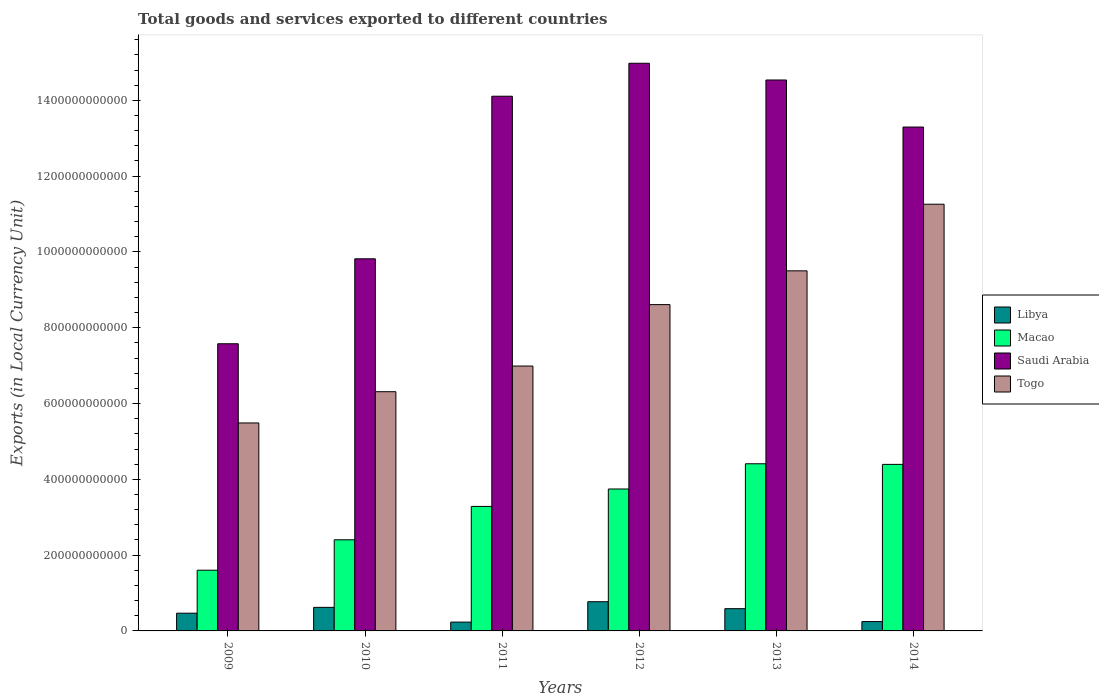How many different coloured bars are there?
Offer a very short reply. 4. How many groups of bars are there?
Offer a very short reply. 6. Are the number of bars on each tick of the X-axis equal?
Offer a very short reply. Yes. How many bars are there on the 5th tick from the left?
Keep it short and to the point. 4. How many bars are there on the 2nd tick from the right?
Your answer should be compact. 4. What is the label of the 2nd group of bars from the left?
Provide a short and direct response. 2010. In how many cases, is the number of bars for a given year not equal to the number of legend labels?
Provide a succinct answer. 0. What is the Amount of goods and services exports in Libya in 2011?
Your answer should be very brief. 2.33e+1. Across all years, what is the maximum Amount of goods and services exports in Togo?
Provide a short and direct response. 1.13e+12. Across all years, what is the minimum Amount of goods and services exports in Saudi Arabia?
Your answer should be compact. 7.58e+11. In which year was the Amount of goods and services exports in Macao maximum?
Ensure brevity in your answer.  2013. In which year was the Amount of goods and services exports in Libya minimum?
Make the answer very short. 2011. What is the total Amount of goods and services exports in Togo in the graph?
Offer a terse response. 4.82e+12. What is the difference between the Amount of goods and services exports in Macao in 2012 and that in 2013?
Offer a very short reply. -6.66e+1. What is the difference between the Amount of goods and services exports in Libya in 2010 and the Amount of goods and services exports in Macao in 2014?
Your answer should be compact. -3.77e+11. What is the average Amount of goods and services exports in Macao per year?
Give a very brief answer. 3.31e+11. In the year 2011, what is the difference between the Amount of goods and services exports in Saudi Arabia and Amount of goods and services exports in Macao?
Your response must be concise. 1.08e+12. What is the ratio of the Amount of goods and services exports in Libya in 2011 to that in 2012?
Provide a short and direct response. 0.3. Is the difference between the Amount of goods and services exports in Saudi Arabia in 2010 and 2012 greater than the difference between the Amount of goods and services exports in Macao in 2010 and 2012?
Your response must be concise. No. What is the difference between the highest and the second highest Amount of goods and services exports in Libya?
Give a very brief answer. 1.49e+1. What is the difference between the highest and the lowest Amount of goods and services exports in Libya?
Make the answer very short. 5.38e+1. Is it the case that in every year, the sum of the Amount of goods and services exports in Libya and Amount of goods and services exports in Togo is greater than the sum of Amount of goods and services exports in Macao and Amount of goods and services exports in Saudi Arabia?
Offer a very short reply. No. What does the 2nd bar from the left in 2012 represents?
Keep it short and to the point. Macao. What does the 2nd bar from the right in 2012 represents?
Provide a short and direct response. Saudi Arabia. Is it the case that in every year, the sum of the Amount of goods and services exports in Libya and Amount of goods and services exports in Togo is greater than the Amount of goods and services exports in Macao?
Give a very brief answer. Yes. How many bars are there?
Provide a succinct answer. 24. How many years are there in the graph?
Provide a short and direct response. 6. What is the difference between two consecutive major ticks on the Y-axis?
Offer a very short reply. 2.00e+11. Are the values on the major ticks of Y-axis written in scientific E-notation?
Keep it short and to the point. No. Does the graph contain any zero values?
Your answer should be very brief. No. Does the graph contain grids?
Offer a terse response. No. Where does the legend appear in the graph?
Offer a terse response. Center right. How many legend labels are there?
Keep it short and to the point. 4. What is the title of the graph?
Ensure brevity in your answer.  Total goods and services exported to different countries. What is the label or title of the X-axis?
Give a very brief answer. Years. What is the label or title of the Y-axis?
Ensure brevity in your answer.  Exports (in Local Currency Unit). What is the Exports (in Local Currency Unit) in Libya in 2009?
Provide a succinct answer. 4.68e+1. What is the Exports (in Local Currency Unit) of Macao in 2009?
Make the answer very short. 1.60e+11. What is the Exports (in Local Currency Unit) in Saudi Arabia in 2009?
Your response must be concise. 7.58e+11. What is the Exports (in Local Currency Unit) in Togo in 2009?
Offer a very short reply. 5.49e+11. What is the Exports (in Local Currency Unit) in Libya in 2010?
Offer a terse response. 6.21e+1. What is the Exports (in Local Currency Unit) in Macao in 2010?
Your answer should be very brief. 2.40e+11. What is the Exports (in Local Currency Unit) in Saudi Arabia in 2010?
Make the answer very short. 9.82e+11. What is the Exports (in Local Currency Unit) of Togo in 2010?
Your response must be concise. 6.31e+11. What is the Exports (in Local Currency Unit) in Libya in 2011?
Your response must be concise. 2.33e+1. What is the Exports (in Local Currency Unit) in Macao in 2011?
Your answer should be very brief. 3.29e+11. What is the Exports (in Local Currency Unit) of Saudi Arabia in 2011?
Give a very brief answer. 1.41e+12. What is the Exports (in Local Currency Unit) in Togo in 2011?
Your answer should be very brief. 6.99e+11. What is the Exports (in Local Currency Unit) of Libya in 2012?
Your answer should be very brief. 7.71e+1. What is the Exports (in Local Currency Unit) of Macao in 2012?
Keep it short and to the point. 3.74e+11. What is the Exports (in Local Currency Unit) of Saudi Arabia in 2012?
Offer a very short reply. 1.50e+12. What is the Exports (in Local Currency Unit) in Togo in 2012?
Give a very brief answer. 8.61e+11. What is the Exports (in Local Currency Unit) in Libya in 2013?
Offer a very short reply. 5.87e+1. What is the Exports (in Local Currency Unit) of Macao in 2013?
Give a very brief answer. 4.41e+11. What is the Exports (in Local Currency Unit) of Saudi Arabia in 2013?
Provide a short and direct response. 1.45e+12. What is the Exports (in Local Currency Unit) of Togo in 2013?
Your response must be concise. 9.50e+11. What is the Exports (in Local Currency Unit) of Libya in 2014?
Provide a succinct answer. 2.46e+1. What is the Exports (in Local Currency Unit) of Macao in 2014?
Keep it short and to the point. 4.39e+11. What is the Exports (in Local Currency Unit) in Saudi Arabia in 2014?
Provide a short and direct response. 1.33e+12. What is the Exports (in Local Currency Unit) in Togo in 2014?
Offer a very short reply. 1.13e+12. Across all years, what is the maximum Exports (in Local Currency Unit) of Libya?
Provide a short and direct response. 7.71e+1. Across all years, what is the maximum Exports (in Local Currency Unit) of Macao?
Keep it short and to the point. 4.41e+11. Across all years, what is the maximum Exports (in Local Currency Unit) in Saudi Arabia?
Make the answer very short. 1.50e+12. Across all years, what is the maximum Exports (in Local Currency Unit) of Togo?
Your answer should be very brief. 1.13e+12. Across all years, what is the minimum Exports (in Local Currency Unit) in Libya?
Your response must be concise. 2.33e+1. Across all years, what is the minimum Exports (in Local Currency Unit) of Macao?
Offer a very short reply. 1.60e+11. Across all years, what is the minimum Exports (in Local Currency Unit) in Saudi Arabia?
Your response must be concise. 7.58e+11. Across all years, what is the minimum Exports (in Local Currency Unit) of Togo?
Provide a succinct answer. 5.49e+11. What is the total Exports (in Local Currency Unit) in Libya in the graph?
Make the answer very short. 2.93e+11. What is the total Exports (in Local Currency Unit) in Macao in the graph?
Your answer should be very brief. 1.98e+12. What is the total Exports (in Local Currency Unit) of Saudi Arabia in the graph?
Give a very brief answer. 7.43e+12. What is the total Exports (in Local Currency Unit) of Togo in the graph?
Your answer should be compact. 4.82e+12. What is the difference between the Exports (in Local Currency Unit) of Libya in 2009 and that in 2010?
Give a very brief answer. -1.53e+1. What is the difference between the Exports (in Local Currency Unit) in Macao in 2009 and that in 2010?
Your response must be concise. -8.02e+1. What is the difference between the Exports (in Local Currency Unit) of Saudi Arabia in 2009 and that in 2010?
Your answer should be compact. -2.24e+11. What is the difference between the Exports (in Local Currency Unit) of Togo in 2009 and that in 2010?
Your response must be concise. -8.24e+1. What is the difference between the Exports (in Local Currency Unit) in Libya in 2009 and that in 2011?
Offer a terse response. 2.35e+1. What is the difference between the Exports (in Local Currency Unit) of Macao in 2009 and that in 2011?
Offer a terse response. -1.68e+11. What is the difference between the Exports (in Local Currency Unit) in Saudi Arabia in 2009 and that in 2011?
Provide a short and direct response. -6.53e+11. What is the difference between the Exports (in Local Currency Unit) in Togo in 2009 and that in 2011?
Give a very brief answer. -1.50e+11. What is the difference between the Exports (in Local Currency Unit) of Libya in 2009 and that in 2012?
Your response must be concise. -3.03e+1. What is the difference between the Exports (in Local Currency Unit) of Macao in 2009 and that in 2012?
Make the answer very short. -2.14e+11. What is the difference between the Exports (in Local Currency Unit) in Saudi Arabia in 2009 and that in 2012?
Your answer should be very brief. -7.40e+11. What is the difference between the Exports (in Local Currency Unit) in Togo in 2009 and that in 2012?
Offer a terse response. -3.12e+11. What is the difference between the Exports (in Local Currency Unit) of Libya in 2009 and that in 2013?
Provide a succinct answer. -1.19e+1. What is the difference between the Exports (in Local Currency Unit) in Macao in 2009 and that in 2013?
Offer a terse response. -2.81e+11. What is the difference between the Exports (in Local Currency Unit) in Saudi Arabia in 2009 and that in 2013?
Make the answer very short. -6.96e+11. What is the difference between the Exports (in Local Currency Unit) of Togo in 2009 and that in 2013?
Make the answer very short. -4.01e+11. What is the difference between the Exports (in Local Currency Unit) of Libya in 2009 and that in 2014?
Provide a succinct answer. 2.22e+1. What is the difference between the Exports (in Local Currency Unit) in Macao in 2009 and that in 2014?
Provide a succinct answer. -2.79e+11. What is the difference between the Exports (in Local Currency Unit) in Saudi Arabia in 2009 and that in 2014?
Ensure brevity in your answer.  -5.72e+11. What is the difference between the Exports (in Local Currency Unit) in Togo in 2009 and that in 2014?
Provide a succinct answer. -5.77e+11. What is the difference between the Exports (in Local Currency Unit) in Libya in 2010 and that in 2011?
Make the answer very short. 3.89e+1. What is the difference between the Exports (in Local Currency Unit) of Macao in 2010 and that in 2011?
Provide a succinct answer. -8.81e+1. What is the difference between the Exports (in Local Currency Unit) in Saudi Arabia in 2010 and that in 2011?
Your answer should be very brief. -4.29e+11. What is the difference between the Exports (in Local Currency Unit) of Togo in 2010 and that in 2011?
Offer a very short reply. -6.77e+1. What is the difference between the Exports (in Local Currency Unit) of Libya in 2010 and that in 2012?
Give a very brief answer. -1.49e+1. What is the difference between the Exports (in Local Currency Unit) of Macao in 2010 and that in 2012?
Keep it short and to the point. -1.34e+11. What is the difference between the Exports (in Local Currency Unit) in Saudi Arabia in 2010 and that in 2012?
Give a very brief answer. -5.16e+11. What is the difference between the Exports (in Local Currency Unit) in Togo in 2010 and that in 2012?
Give a very brief answer. -2.30e+11. What is the difference between the Exports (in Local Currency Unit) of Libya in 2010 and that in 2013?
Offer a terse response. 3.47e+09. What is the difference between the Exports (in Local Currency Unit) in Macao in 2010 and that in 2013?
Your response must be concise. -2.01e+11. What is the difference between the Exports (in Local Currency Unit) of Saudi Arabia in 2010 and that in 2013?
Your answer should be very brief. -4.72e+11. What is the difference between the Exports (in Local Currency Unit) in Togo in 2010 and that in 2013?
Provide a succinct answer. -3.19e+11. What is the difference between the Exports (in Local Currency Unit) in Libya in 2010 and that in 2014?
Your response must be concise. 3.75e+1. What is the difference between the Exports (in Local Currency Unit) in Macao in 2010 and that in 2014?
Give a very brief answer. -1.99e+11. What is the difference between the Exports (in Local Currency Unit) in Saudi Arabia in 2010 and that in 2014?
Offer a very short reply. -3.48e+11. What is the difference between the Exports (in Local Currency Unit) in Togo in 2010 and that in 2014?
Provide a succinct answer. -4.95e+11. What is the difference between the Exports (in Local Currency Unit) in Libya in 2011 and that in 2012?
Offer a very short reply. -5.38e+1. What is the difference between the Exports (in Local Currency Unit) in Macao in 2011 and that in 2012?
Ensure brevity in your answer.  -4.60e+1. What is the difference between the Exports (in Local Currency Unit) of Saudi Arabia in 2011 and that in 2012?
Your answer should be very brief. -8.70e+1. What is the difference between the Exports (in Local Currency Unit) in Togo in 2011 and that in 2012?
Provide a succinct answer. -1.62e+11. What is the difference between the Exports (in Local Currency Unit) of Libya in 2011 and that in 2013?
Provide a short and direct response. -3.54e+1. What is the difference between the Exports (in Local Currency Unit) of Macao in 2011 and that in 2013?
Your response must be concise. -1.13e+11. What is the difference between the Exports (in Local Currency Unit) in Saudi Arabia in 2011 and that in 2013?
Offer a very short reply. -4.28e+1. What is the difference between the Exports (in Local Currency Unit) in Togo in 2011 and that in 2013?
Your answer should be very brief. -2.51e+11. What is the difference between the Exports (in Local Currency Unit) of Libya in 2011 and that in 2014?
Give a very brief answer. -1.32e+09. What is the difference between the Exports (in Local Currency Unit) of Macao in 2011 and that in 2014?
Your answer should be compact. -1.11e+11. What is the difference between the Exports (in Local Currency Unit) of Saudi Arabia in 2011 and that in 2014?
Provide a succinct answer. 8.13e+1. What is the difference between the Exports (in Local Currency Unit) in Togo in 2011 and that in 2014?
Keep it short and to the point. -4.27e+11. What is the difference between the Exports (in Local Currency Unit) of Libya in 2012 and that in 2013?
Provide a succinct answer. 1.84e+1. What is the difference between the Exports (in Local Currency Unit) in Macao in 2012 and that in 2013?
Offer a terse response. -6.66e+1. What is the difference between the Exports (in Local Currency Unit) in Saudi Arabia in 2012 and that in 2013?
Offer a terse response. 4.42e+1. What is the difference between the Exports (in Local Currency Unit) in Togo in 2012 and that in 2013?
Give a very brief answer. -8.91e+1. What is the difference between the Exports (in Local Currency Unit) of Libya in 2012 and that in 2014?
Offer a terse response. 5.25e+1. What is the difference between the Exports (in Local Currency Unit) in Macao in 2012 and that in 2014?
Give a very brief answer. -6.50e+1. What is the difference between the Exports (in Local Currency Unit) in Saudi Arabia in 2012 and that in 2014?
Keep it short and to the point. 1.68e+11. What is the difference between the Exports (in Local Currency Unit) in Togo in 2012 and that in 2014?
Your answer should be very brief. -2.65e+11. What is the difference between the Exports (in Local Currency Unit) in Libya in 2013 and that in 2014?
Keep it short and to the point. 3.41e+1. What is the difference between the Exports (in Local Currency Unit) of Macao in 2013 and that in 2014?
Ensure brevity in your answer.  1.61e+09. What is the difference between the Exports (in Local Currency Unit) of Saudi Arabia in 2013 and that in 2014?
Your answer should be compact. 1.24e+11. What is the difference between the Exports (in Local Currency Unit) in Togo in 2013 and that in 2014?
Your answer should be compact. -1.76e+11. What is the difference between the Exports (in Local Currency Unit) of Libya in 2009 and the Exports (in Local Currency Unit) of Macao in 2010?
Offer a terse response. -1.94e+11. What is the difference between the Exports (in Local Currency Unit) in Libya in 2009 and the Exports (in Local Currency Unit) in Saudi Arabia in 2010?
Offer a terse response. -9.35e+11. What is the difference between the Exports (in Local Currency Unit) of Libya in 2009 and the Exports (in Local Currency Unit) of Togo in 2010?
Keep it short and to the point. -5.84e+11. What is the difference between the Exports (in Local Currency Unit) in Macao in 2009 and the Exports (in Local Currency Unit) in Saudi Arabia in 2010?
Give a very brief answer. -8.22e+11. What is the difference between the Exports (in Local Currency Unit) in Macao in 2009 and the Exports (in Local Currency Unit) in Togo in 2010?
Give a very brief answer. -4.71e+11. What is the difference between the Exports (in Local Currency Unit) in Saudi Arabia in 2009 and the Exports (in Local Currency Unit) in Togo in 2010?
Offer a terse response. 1.27e+11. What is the difference between the Exports (in Local Currency Unit) in Libya in 2009 and the Exports (in Local Currency Unit) in Macao in 2011?
Offer a terse response. -2.82e+11. What is the difference between the Exports (in Local Currency Unit) of Libya in 2009 and the Exports (in Local Currency Unit) of Saudi Arabia in 2011?
Offer a very short reply. -1.36e+12. What is the difference between the Exports (in Local Currency Unit) in Libya in 2009 and the Exports (in Local Currency Unit) in Togo in 2011?
Provide a short and direct response. -6.52e+11. What is the difference between the Exports (in Local Currency Unit) of Macao in 2009 and the Exports (in Local Currency Unit) of Saudi Arabia in 2011?
Give a very brief answer. -1.25e+12. What is the difference between the Exports (in Local Currency Unit) in Macao in 2009 and the Exports (in Local Currency Unit) in Togo in 2011?
Keep it short and to the point. -5.39e+11. What is the difference between the Exports (in Local Currency Unit) in Saudi Arabia in 2009 and the Exports (in Local Currency Unit) in Togo in 2011?
Your answer should be very brief. 5.88e+1. What is the difference between the Exports (in Local Currency Unit) in Libya in 2009 and the Exports (in Local Currency Unit) in Macao in 2012?
Make the answer very short. -3.28e+11. What is the difference between the Exports (in Local Currency Unit) in Libya in 2009 and the Exports (in Local Currency Unit) in Saudi Arabia in 2012?
Give a very brief answer. -1.45e+12. What is the difference between the Exports (in Local Currency Unit) in Libya in 2009 and the Exports (in Local Currency Unit) in Togo in 2012?
Your answer should be very brief. -8.14e+11. What is the difference between the Exports (in Local Currency Unit) of Macao in 2009 and the Exports (in Local Currency Unit) of Saudi Arabia in 2012?
Your response must be concise. -1.34e+12. What is the difference between the Exports (in Local Currency Unit) of Macao in 2009 and the Exports (in Local Currency Unit) of Togo in 2012?
Provide a succinct answer. -7.01e+11. What is the difference between the Exports (in Local Currency Unit) of Saudi Arabia in 2009 and the Exports (in Local Currency Unit) of Togo in 2012?
Keep it short and to the point. -1.03e+11. What is the difference between the Exports (in Local Currency Unit) of Libya in 2009 and the Exports (in Local Currency Unit) of Macao in 2013?
Make the answer very short. -3.94e+11. What is the difference between the Exports (in Local Currency Unit) of Libya in 2009 and the Exports (in Local Currency Unit) of Saudi Arabia in 2013?
Your answer should be compact. -1.41e+12. What is the difference between the Exports (in Local Currency Unit) of Libya in 2009 and the Exports (in Local Currency Unit) of Togo in 2013?
Your response must be concise. -9.03e+11. What is the difference between the Exports (in Local Currency Unit) in Macao in 2009 and the Exports (in Local Currency Unit) in Saudi Arabia in 2013?
Provide a short and direct response. -1.29e+12. What is the difference between the Exports (in Local Currency Unit) of Macao in 2009 and the Exports (in Local Currency Unit) of Togo in 2013?
Keep it short and to the point. -7.90e+11. What is the difference between the Exports (in Local Currency Unit) in Saudi Arabia in 2009 and the Exports (in Local Currency Unit) in Togo in 2013?
Offer a terse response. -1.92e+11. What is the difference between the Exports (in Local Currency Unit) of Libya in 2009 and the Exports (in Local Currency Unit) of Macao in 2014?
Keep it short and to the point. -3.93e+11. What is the difference between the Exports (in Local Currency Unit) of Libya in 2009 and the Exports (in Local Currency Unit) of Saudi Arabia in 2014?
Your answer should be very brief. -1.28e+12. What is the difference between the Exports (in Local Currency Unit) of Libya in 2009 and the Exports (in Local Currency Unit) of Togo in 2014?
Your answer should be compact. -1.08e+12. What is the difference between the Exports (in Local Currency Unit) in Macao in 2009 and the Exports (in Local Currency Unit) in Saudi Arabia in 2014?
Your response must be concise. -1.17e+12. What is the difference between the Exports (in Local Currency Unit) in Macao in 2009 and the Exports (in Local Currency Unit) in Togo in 2014?
Ensure brevity in your answer.  -9.66e+11. What is the difference between the Exports (in Local Currency Unit) of Saudi Arabia in 2009 and the Exports (in Local Currency Unit) of Togo in 2014?
Ensure brevity in your answer.  -3.68e+11. What is the difference between the Exports (in Local Currency Unit) in Libya in 2010 and the Exports (in Local Currency Unit) in Macao in 2011?
Provide a short and direct response. -2.66e+11. What is the difference between the Exports (in Local Currency Unit) in Libya in 2010 and the Exports (in Local Currency Unit) in Saudi Arabia in 2011?
Keep it short and to the point. -1.35e+12. What is the difference between the Exports (in Local Currency Unit) of Libya in 2010 and the Exports (in Local Currency Unit) of Togo in 2011?
Offer a very short reply. -6.37e+11. What is the difference between the Exports (in Local Currency Unit) of Macao in 2010 and the Exports (in Local Currency Unit) of Saudi Arabia in 2011?
Provide a short and direct response. -1.17e+12. What is the difference between the Exports (in Local Currency Unit) of Macao in 2010 and the Exports (in Local Currency Unit) of Togo in 2011?
Provide a succinct answer. -4.58e+11. What is the difference between the Exports (in Local Currency Unit) of Saudi Arabia in 2010 and the Exports (in Local Currency Unit) of Togo in 2011?
Your response must be concise. 2.83e+11. What is the difference between the Exports (in Local Currency Unit) of Libya in 2010 and the Exports (in Local Currency Unit) of Macao in 2012?
Keep it short and to the point. -3.12e+11. What is the difference between the Exports (in Local Currency Unit) in Libya in 2010 and the Exports (in Local Currency Unit) in Saudi Arabia in 2012?
Give a very brief answer. -1.44e+12. What is the difference between the Exports (in Local Currency Unit) of Libya in 2010 and the Exports (in Local Currency Unit) of Togo in 2012?
Provide a succinct answer. -7.99e+11. What is the difference between the Exports (in Local Currency Unit) of Macao in 2010 and the Exports (in Local Currency Unit) of Saudi Arabia in 2012?
Make the answer very short. -1.26e+12. What is the difference between the Exports (in Local Currency Unit) in Macao in 2010 and the Exports (in Local Currency Unit) in Togo in 2012?
Offer a terse response. -6.21e+11. What is the difference between the Exports (in Local Currency Unit) of Saudi Arabia in 2010 and the Exports (in Local Currency Unit) of Togo in 2012?
Make the answer very short. 1.21e+11. What is the difference between the Exports (in Local Currency Unit) of Libya in 2010 and the Exports (in Local Currency Unit) of Macao in 2013?
Provide a succinct answer. -3.79e+11. What is the difference between the Exports (in Local Currency Unit) in Libya in 2010 and the Exports (in Local Currency Unit) in Saudi Arabia in 2013?
Offer a very short reply. -1.39e+12. What is the difference between the Exports (in Local Currency Unit) in Libya in 2010 and the Exports (in Local Currency Unit) in Togo in 2013?
Your answer should be compact. -8.88e+11. What is the difference between the Exports (in Local Currency Unit) in Macao in 2010 and the Exports (in Local Currency Unit) in Saudi Arabia in 2013?
Provide a succinct answer. -1.21e+12. What is the difference between the Exports (in Local Currency Unit) in Macao in 2010 and the Exports (in Local Currency Unit) in Togo in 2013?
Offer a very short reply. -7.10e+11. What is the difference between the Exports (in Local Currency Unit) in Saudi Arabia in 2010 and the Exports (in Local Currency Unit) in Togo in 2013?
Give a very brief answer. 3.18e+1. What is the difference between the Exports (in Local Currency Unit) in Libya in 2010 and the Exports (in Local Currency Unit) in Macao in 2014?
Your answer should be compact. -3.77e+11. What is the difference between the Exports (in Local Currency Unit) of Libya in 2010 and the Exports (in Local Currency Unit) of Saudi Arabia in 2014?
Your response must be concise. -1.27e+12. What is the difference between the Exports (in Local Currency Unit) in Libya in 2010 and the Exports (in Local Currency Unit) in Togo in 2014?
Your answer should be compact. -1.06e+12. What is the difference between the Exports (in Local Currency Unit) in Macao in 2010 and the Exports (in Local Currency Unit) in Saudi Arabia in 2014?
Offer a very short reply. -1.09e+12. What is the difference between the Exports (in Local Currency Unit) of Macao in 2010 and the Exports (in Local Currency Unit) of Togo in 2014?
Your answer should be compact. -8.85e+11. What is the difference between the Exports (in Local Currency Unit) of Saudi Arabia in 2010 and the Exports (in Local Currency Unit) of Togo in 2014?
Your answer should be very brief. -1.44e+11. What is the difference between the Exports (in Local Currency Unit) of Libya in 2011 and the Exports (in Local Currency Unit) of Macao in 2012?
Your answer should be very brief. -3.51e+11. What is the difference between the Exports (in Local Currency Unit) in Libya in 2011 and the Exports (in Local Currency Unit) in Saudi Arabia in 2012?
Provide a short and direct response. -1.47e+12. What is the difference between the Exports (in Local Currency Unit) in Libya in 2011 and the Exports (in Local Currency Unit) in Togo in 2012?
Your response must be concise. -8.38e+11. What is the difference between the Exports (in Local Currency Unit) of Macao in 2011 and the Exports (in Local Currency Unit) of Saudi Arabia in 2012?
Ensure brevity in your answer.  -1.17e+12. What is the difference between the Exports (in Local Currency Unit) in Macao in 2011 and the Exports (in Local Currency Unit) in Togo in 2012?
Give a very brief answer. -5.32e+11. What is the difference between the Exports (in Local Currency Unit) in Saudi Arabia in 2011 and the Exports (in Local Currency Unit) in Togo in 2012?
Ensure brevity in your answer.  5.50e+11. What is the difference between the Exports (in Local Currency Unit) of Libya in 2011 and the Exports (in Local Currency Unit) of Macao in 2013?
Make the answer very short. -4.18e+11. What is the difference between the Exports (in Local Currency Unit) of Libya in 2011 and the Exports (in Local Currency Unit) of Saudi Arabia in 2013?
Provide a short and direct response. -1.43e+12. What is the difference between the Exports (in Local Currency Unit) in Libya in 2011 and the Exports (in Local Currency Unit) in Togo in 2013?
Your response must be concise. -9.27e+11. What is the difference between the Exports (in Local Currency Unit) in Macao in 2011 and the Exports (in Local Currency Unit) in Saudi Arabia in 2013?
Offer a terse response. -1.13e+12. What is the difference between the Exports (in Local Currency Unit) of Macao in 2011 and the Exports (in Local Currency Unit) of Togo in 2013?
Your answer should be compact. -6.22e+11. What is the difference between the Exports (in Local Currency Unit) of Saudi Arabia in 2011 and the Exports (in Local Currency Unit) of Togo in 2013?
Ensure brevity in your answer.  4.61e+11. What is the difference between the Exports (in Local Currency Unit) of Libya in 2011 and the Exports (in Local Currency Unit) of Macao in 2014?
Offer a very short reply. -4.16e+11. What is the difference between the Exports (in Local Currency Unit) of Libya in 2011 and the Exports (in Local Currency Unit) of Saudi Arabia in 2014?
Offer a very short reply. -1.31e+12. What is the difference between the Exports (in Local Currency Unit) of Libya in 2011 and the Exports (in Local Currency Unit) of Togo in 2014?
Keep it short and to the point. -1.10e+12. What is the difference between the Exports (in Local Currency Unit) of Macao in 2011 and the Exports (in Local Currency Unit) of Saudi Arabia in 2014?
Make the answer very short. -1.00e+12. What is the difference between the Exports (in Local Currency Unit) of Macao in 2011 and the Exports (in Local Currency Unit) of Togo in 2014?
Offer a terse response. -7.97e+11. What is the difference between the Exports (in Local Currency Unit) in Saudi Arabia in 2011 and the Exports (in Local Currency Unit) in Togo in 2014?
Your answer should be compact. 2.85e+11. What is the difference between the Exports (in Local Currency Unit) in Libya in 2012 and the Exports (in Local Currency Unit) in Macao in 2013?
Give a very brief answer. -3.64e+11. What is the difference between the Exports (in Local Currency Unit) in Libya in 2012 and the Exports (in Local Currency Unit) in Saudi Arabia in 2013?
Provide a succinct answer. -1.38e+12. What is the difference between the Exports (in Local Currency Unit) in Libya in 2012 and the Exports (in Local Currency Unit) in Togo in 2013?
Your answer should be compact. -8.73e+11. What is the difference between the Exports (in Local Currency Unit) of Macao in 2012 and the Exports (in Local Currency Unit) of Saudi Arabia in 2013?
Your answer should be compact. -1.08e+12. What is the difference between the Exports (in Local Currency Unit) of Macao in 2012 and the Exports (in Local Currency Unit) of Togo in 2013?
Your answer should be compact. -5.76e+11. What is the difference between the Exports (in Local Currency Unit) of Saudi Arabia in 2012 and the Exports (in Local Currency Unit) of Togo in 2013?
Offer a very short reply. 5.48e+11. What is the difference between the Exports (in Local Currency Unit) of Libya in 2012 and the Exports (in Local Currency Unit) of Macao in 2014?
Provide a succinct answer. -3.62e+11. What is the difference between the Exports (in Local Currency Unit) of Libya in 2012 and the Exports (in Local Currency Unit) of Saudi Arabia in 2014?
Give a very brief answer. -1.25e+12. What is the difference between the Exports (in Local Currency Unit) of Libya in 2012 and the Exports (in Local Currency Unit) of Togo in 2014?
Your answer should be very brief. -1.05e+12. What is the difference between the Exports (in Local Currency Unit) in Macao in 2012 and the Exports (in Local Currency Unit) in Saudi Arabia in 2014?
Offer a very short reply. -9.55e+11. What is the difference between the Exports (in Local Currency Unit) of Macao in 2012 and the Exports (in Local Currency Unit) of Togo in 2014?
Keep it short and to the point. -7.51e+11. What is the difference between the Exports (in Local Currency Unit) of Saudi Arabia in 2012 and the Exports (in Local Currency Unit) of Togo in 2014?
Make the answer very short. 3.72e+11. What is the difference between the Exports (in Local Currency Unit) of Libya in 2013 and the Exports (in Local Currency Unit) of Macao in 2014?
Offer a very short reply. -3.81e+11. What is the difference between the Exports (in Local Currency Unit) in Libya in 2013 and the Exports (in Local Currency Unit) in Saudi Arabia in 2014?
Your response must be concise. -1.27e+12. What is the difference between the Exports (in Local Currency Unit) of Libya in 2013 and the Exports (in Local Currency Unit) of Togo in 2014?
Offer a terse response. -1.07e+12. What is the difference between the Exports (in Local Currency Unit) of Macao in 2013 and the Exports (in Local Currency Unit) of Saudi Arabia in 2014?
Your response must be concise. -8.88e+11. What is the difference between the Exports (in Local Currency Unit) in Macao in 2013 and the Exports (in Local Currency Unit) in Togo in 2014?
Keep it short and to the point. -6.85e+11. What is the difference between the Exports (in Local Currency Unit) in Saudi Arabia in 2013 and the Exports (in Local Currency Unit) in Togo in 2014?
Provide a short and direct response. 3.28e+11. What is the average Exports (in Local Currency Unit) in Libya per year?
Offer a terse response. 4.88e+1. What is the average Exports (in Local Currency Unit) of Macao per year?
Provide a succinct answer. 3.31e+11. What is the average Exports (in Local Currency Unit) of Saudi Arabia per year?
Ensure brevity in your answer.  1.24e+12. What is the average Exports (in Local Currency Unit) of Togo per year?
Keep it short and to the point. 8.03e+11. In the year 2009, what is the difference between the Exports (in Local Currency Unit) in Libya and Exports (in Local Currency Unit) in Macao?
Your answer should be compact. -1.13e+11. In the year 2009, what is the difference between the Exports (in Local Currency Unit) in Libya and Exports (in Local Currency Unit) in Saudi Arabia?
Give a very brief answer. -7.11e+11. In the year 2009, what is the difference between the Exports (in Local Currency Unit) in Libya and Exports (in Local Currency Unit) in Togo?
Your response must be concise. -5.02e+11. In the year 2009, what is the difference between the Exports (in Local Currency Unit) in Macao and Exports (in Local Currency Unit) in Saudi Arabia?
Your answer should be compact. -5.98e+11. In the year 2009, what is the difference between the Exports (in Local Currency Unit) in Macao and Exports (in Local Currency Unit) in Togo?
Provide a short and direct response. -3.89e+11. In the year 2009, what is the difference between the Exports (in Local Currency Unit) of Saudi Arabia and Exports (in Local Currency Unit) of Togo?
Provide a succinct answer. 2.09e+11. In the year 2010, what is the difference between the Exports (in Local Currency Unit) in Libya and Exports (in Local Currency Unit) in Macao?
Your answer should be very brief. -1.78e+11. In the year 2010, what is the difference between the Exports (in Local Currency Unit) of Libya and Exports (in Local Currency Unit) of Saudi Arabia?
Your answer should be very brief. -9.20e+11. In the year 2010, what is the difference between the Exports (in Local Currency Unit) in Libya and Exports (in Local Currency Unit) in Togo?
Provide a succinct answer. -5.69e+11. In the year 2010, what is the difference between the Exports (in Local Currency Unit) in Macao and Exports (in Local Currency Unit) in Saudi Arabia?
Your answer should be very brief. -7.41e+11. In the year 2010, what is the difference between the Exports (in Local Currency Unit) of Macao and Exports (in Local Currency Unit) of Togo?
Your answer should be very brief. -3.91e+11. In the year 2010, what is the difference between the Exports (in Local Currency Unit) in Saudi Arabia and Exports (in Local Currency Unit) in Togo?
Your answer should be very brief. 3.51e+11. In the year 2011, what is the difference between the Exports (in Local Currency Unit) of Libya and Exports (in Local Currency Unit) of Macao?
Offer a terse response. -3.05e+11. In the year 2011, what is the difference between the Exports (in Local Currency Unit) in Libya and Exports (in Local Currency Unit) in Saudi Arabia?
Your answer should be very brief. -1.39e+12. In the year 2011, what is the difference between the Exports (in Local Currency Unit) of Libya and Exports (in Local Currency Unit) of Togo?
Provide a short and direct response. -6.76e+11. In the year 2011, what is the difference between the Exports (in Local Currency Unit) of Macao and Exports (in Local Currency Unit) of Saudi Arabia?
Your answer should be very brief. -1.08e+12. In the year 2011, what is the difference between the Exports (in Local Currency Unit) in Macao and Exports (in Local Currency Unit) in Togo?
Provide a short and direct response. -3.70e+11. In the year 2011, what is the difference between the Exports (in Local Currency Unit) of Saudi Arabia and Exports (in Local Currency Unit) of Togo?
Make the answer very short. 7.12e+11. In the year 2012, what is the difference between the Exports (in Local Currency Unit) in Libya and Exports (in Local Currency Unit) in Macao?
Offer a very short reply. -2.97e+11. In the year 2012, what is the difference between the Exports (in Local Currency Unit) in Libya and Exports (in Local Currency Unit) in Saudi Arabia?
Offer a terse response. -1.42e+12. In the year 2012, what is the difference between the Exports (in Local Currency Unit) of Libya and Exports (in Local Currency Unit) of Togo?
Provide a succinct answer. -7.84e+11. In the year 2012, what is the difference between the Exports (in Local Currency Unit) in Macao and Exports (in Local Currency Unit) in Saudi Arabia?
Offer a terse response. -1.12e+12. In the year 2012, what is the difference between the Exports (in Local Currency Unit) in Macao and Exports (in Local Currency Unit) in Togo?
Keep it short and to the point. -4.87e+11. In the year 2012, what is the difference between the Exports (in Local Currency Unit) of Saudi Arabia and Exports (in Local Currency Unit) of Togo?
Your answer should be very brief. 6.37e+11. In the year 2013, what is the difference between the Exports (in Local Currency Unit) in Libya and Exports (in Local Currency Unit) in Macao?
Give a very brief answer. -3.82e+11. In the year 2013, what is the difference between the Exports (in Local Currency Unit) in Libya and Exports (in Local Currency Unit) in Saudi Arabia?
Offer a terse response. -1.39e+12. In the year 2013, what is the difference between the Exports (in Local Currency Unit) in Libya and Exports (in Local Currency Unit) in Togo?
Your answer should be compact. -8.91e+11. In the year 2013, what is the difference between the Exports (in Local Currency Unit) in Macao and Exports (in Local Currency Unit) in Saudi Arabia?
Provide a short and direct response. -1.01e+12. In the year 2013, what is the difference between the Exports (in Local Currency Unit) in Macao and Exports (in Local Currency Unit) in Togo?
Make the answer very short. -5.09e+11. In the year 2013, what is the difference between the Exports (in Local Currency Unit) in Saudi Arabia and Exports (in Local Currency Unit) in Togo?
Make the answer very short. 5.04e+11. In the year 2014, what is the difference between the Exports (in Local Currency Unit) in Libya and Exports (in Local Currency Unit) in Macao?
Your answer should be compact. -4.15e+11. In the year 2014, what is the difference between the Exports (in Local Currency Unit) in Libya and Exports (in Local Currency Unit) in Saudi Arabia?
Give a very brief answer. -1.30e+12. In the year 2014, what is the difference between the Exports (in Local Currency Unit) in Libya and Exports (in Local Currency Unit) in Togo?
Your response must be concise. -1.10e+12. In the year 2014, what is the difference between the Exports (in Local Currency Unit) in Macao and Exports (in Local Currency Unit) in Saudi Arabia?
Ensure brevity in your answer.  -8.90e+11. In the year 2014, what is the difference between the Exports (in Local Currency Unit) of Macao and Exports (in Local Currency Unit) of Togo?
Ensure brevity in your answer.  -6.86e+11. In the year 2014, what is the difference between the Exports (in Local Currency Unit) of Saudi Arabia and Exports (in Local Currency Unit) of Togo?
Your response must be concise. 2.04e+11. What is the ratio of the Exports (in Local Currency Unit) in Libya in 2009 to that in 2010?
Offer a very short reply. 0.75. What is the ratio of the Exports (in Local Currency Unit) of Macao in 2009 to that in 2010?
Provide a short and direct response. 0.67. What is the ratio of the Exports (in Local Currency Unit) of Saudi Arabia in 2009 to that in 2010?
Your response must be concise. 0.77. What is the ratio of the Exports (in Local Currency Unit) in Togo in 2009 to that in 2010?
Keep it short and to the point. 0.87. What is the ratio of the Exports (in Local Currency Unit) of Libya in 2009 to that in 2011?
Ensure brevity in your answer.  2.01. What is the ratio of the Exports (in Local Currency Unit) of Macao in 2009 to that in 2011?
Offer a terse response. 0.49. What is the ratio of the Exports (in Local Currency Unit) of Saudi Arabia in 2009 to that in 2011?
Keep it short and to the point. 0.54. What is the ratio of the Exports (in Local Currency Unit) in Togo in 2009 to that in 2011?
Provide a short and direct response. 0.79. What is the ratio of the Exports (in Local Currency Unit) of Libya in 2009 to that in 2012?
Ensure brevity in your answer.  0.61. What is the ratio of the Exports (in Local Currency Unit) of Macao in 2009 to that in 2012?
Provide a succinct answer. 0.43. What is the ratio of the Exports (in Local Currency Unit) of Saudi Arabia in 2009 to that in 2012?
Offer a very short reply. 0.51. What is the ratio of the Exports (in Local Currency Unit) of Togo in 2009 to that in 2012?
Provide a short and direct response. 0.64. What is the ratio of the Exports (in Local Currency Unit) of Libya in 2009 to that in 2013?
Provide a succinct answer. 0.8. What is the ratio of the Exports (in Local Currency Unit) of Macao in 2009 to that in 2013?
Your answer should be compact. 0.36. What is the ratio of the Exports (in Local Currency Unit) of Saudi Arabia in 2009 to that in 2013?
Give a very brief answer. 0.52. What is the ratio of the Exports (in Local Currency Unit) of Togo in 2009 to that in 2013?
Your answer should be compact. 0.58. What is the ratio of the Exports (in Local Currency Unit) of Libya in 2009 to that in 2014?
Your answer should be very brief. 1.9. What is the ratio of the Exports (in Local Currency Unit) of Macao in 2009 to that in 2014?
Your response must be concise. 0.36. What is the ratio of the Exports (in Local Currency Unit) of Saudi Arabia in 2009 to that in 2014?
Your answer should be very brief. 0.57. What is the ratio of the Exports (in Local Currency Unit) of Togo in 2009 to that in 2014?
Provide a succinct answer. 0.49. What is the ratio of the Exports (in Local Currency Unit) of Libya in 2010 to that in 2011?
Offer a terse response. 2.67. What is the ratio of the Exports (in Local Currency Unit) in Macao in 2010 to that in 2011?
Your answer should be compact. 0.73. What is the ratio of the Exports (in Local Currency Unit) of Saudi Arabia in 2010 to that in 2011?
Give a very brief answer. 0.7. What is the ratio of the Exports (in Local Currency Unit) in Togo in 2010 to that in 2011?
Your answer should be very brief. 0.9. What is the ratio of the Exports (in Local Currency Unit) in Libya in 2010 to that in 2012?
Make the answer very short. 0.81. What is the ratio of the Exports (in Local Currency Unit) in Macao in 2010 to that in 2012?
Your response must be concise. 0.64. What is the ratio of the Exports (in Local Currency Unit) in Saudi Arabia in 2010 to that in 2012?
Ensure brevity in your answer.  0.66. What is the ratio of the Exports (in Local Currency Unit) in Togo in 2010 to that in 2012?
Offer a terse response. 0.73. What is the ratio of the Exports (in Local Currency Unit) of Libya in 2010 to that in 2013?
Your answer should be very brief. 1.06. What is the ratio of the Exports (in Local Currency Unit) of Macao in 2010 to that in 2013?
Your answer should be very brief. 0.55. What is the ratio of the Exports (in Local Currency Unit) of Saudi Arabia in 2010 to that in 2013?
Provide a short and direct response. 0.68. What is the ratio of the Exports (in Local Currency Unit) of Togo in 2010 to that in 2013?
Offer a very short reply. 0.66. What is the ratio of the Exports (in Local Currency Unit) in Libya in 2010 to that in 2014?
Give a very brief answer. 2.52. What is the ratio of the Exports (in Local Currency Unit) in Macao in 2010 to that in 2014?
Your answer should be very brief. 0.55. What is the ratio of the Exports (in Local Currency Unit) of Saudi Arabia in 2010 to that in 2014?
Make the answer very short. 0.74. What is the ratio of the Exports (in Local Currency Unit) of Togo in 2010 to that in 2014?
Provide a short and direct response. 0.56. What is the ratio of the Exports (in Local Currency Unit) of Libya in 2011 to that in 2012?
Give a very brief answer. 0.3. What is the ratio of the Exports (in Local Currency Unit) of Macao in 2011 to that in 2012?
Your response must be concise. 0.88. What is the ratio of the Exports (in Local Currency Unit) in Saudi Arabia in 2011 to that in 2012?
Provide a succinct answer. 0.94. What is the ratio of the Exports (in Local Currency Unit) in Togo in 2011 to that in 2012?
Offer a very short reply. 0.81. What is the ratio of the Exports (in Local Currency Unit) in Libya in 2011 to that in 2013?
Your response must be concise. 0.4. What is the ratio of the Exports (in Local Currency Unit) of Macao in 2011 to that in 2013?
Offer a terse response. 0.74. What is the ratio of the Exports (in Local Currency Unit) in Saudi Arabia in 2011 to that in 2013?
Provide a short and direct response. 0.97. What is the ratio of the Exports (in Local Currency Unit) in Togo in 2011 to that in 2013?
Provide a short and direct response. 0.74. What is the ratio of the Exports (in Local Currency Unit) in Libya in 2011 to that in 2014?
Your response must be concise. 0.95. What is the ratio of the Exports (in Local Currency Unit) in Macao in 2011 to that in 2014?
Provide a short and direct response. 0.75. What is the ratio of the Exports (in Local Currency Unit) in Saudi Arabia in 2011 to that in 2014?
Offer a terse response. 1.06. What is the ratio of the Exports (in Local Currency Unit) of Togo in 2011 to that in 2014?
Give a very brief answer. 0.62. What is the ratio of the Exports (in Local Currency Unit) of Libya in 2012 to that in 2013?
Provide a short and direct response. 1.31. What is the ratio of the Exports (in Local Currency Unit) of Macao in 2012 to that in 2013?
Offer a very short reply. 0.85. What is the ratio of the Exports (in Local Currency Unit) in Saudi Arabia in 2012 to that in 2013?
Your answer should be very brief. 1.03. What is the ratio of the Exports (in Local Currency Unit) in Togo in 2012 to that in 2013?
Give a very brief answer. 0.91. What is the ratio of the Exports (in Local Currency Unit) in Libya in 2012 to that in 2014?
Your response must be concise. 3.13. What is the ratio of the Exports (in Local Currency Unit) of Macao in 2012 to that in 2014?
Offer a very short reply. 0.85. What is the ratio of the Exports (in Local Currency Unit) in Saudi Arabia in 2012 to that in 2014?
Provide a succinct answer. 1.13. What is the ratio of the Exports (in Local Currency Unit) of Togo in 2012 to that in 2014?
Make the answer very short. 0.76. What is the ratio of the Exports (in Local Currency Unit) in Libya in 2013 to that in 2014?
Give a very brief answer. 2.38. What is the ratio of the Exports (in Local Currency Unit) of Saudi Arabia in 2013 to that in 2014?
Your answer should be very brief. 1.09. What is the ratio of the Exports (in Local Currency Unit) of Togo in 2013 to that in 2014?
Make the answer very short. 0.84. What is the difference between the highest and the second highest Exports (in Local Currency Unit) of Libya?
Your response must be concise. 1.49e+1. What is the difference between the highest and the second highest Exports (in Local Currency Unit) of Macao?
Ensure brevity in your answer.  1.61e+09. What is the difference between the highest and the second highest Exports (in Local Currency Unit) in Saudi Arabia?
Keep it short and to the point. 4.42e+1. What is the difference between the highest and the second highest Exports (in Local Currency Unit) of Togo?
Offer a terse response. 1.76e+11. What is the difference between the highest and the lowest Exports (in Local Currency Unit) of Libya?
Provide a short and direct response. 5.38e+1. What is the difference between the highest and the lowest Exports (in Local Currency Unit) in Macao?
Provide a short and direct response. 2.81e+11. What is the difference between the highest and the lowest Exports (in Local Currency Unit) in Saudi Arabia?
Offer a very short reply. 7.40e+11. What is the difference between the highest and the lowest Exports (in Local Currency Unit) in Togo?
Offer a terse response. 5.77e+11. 